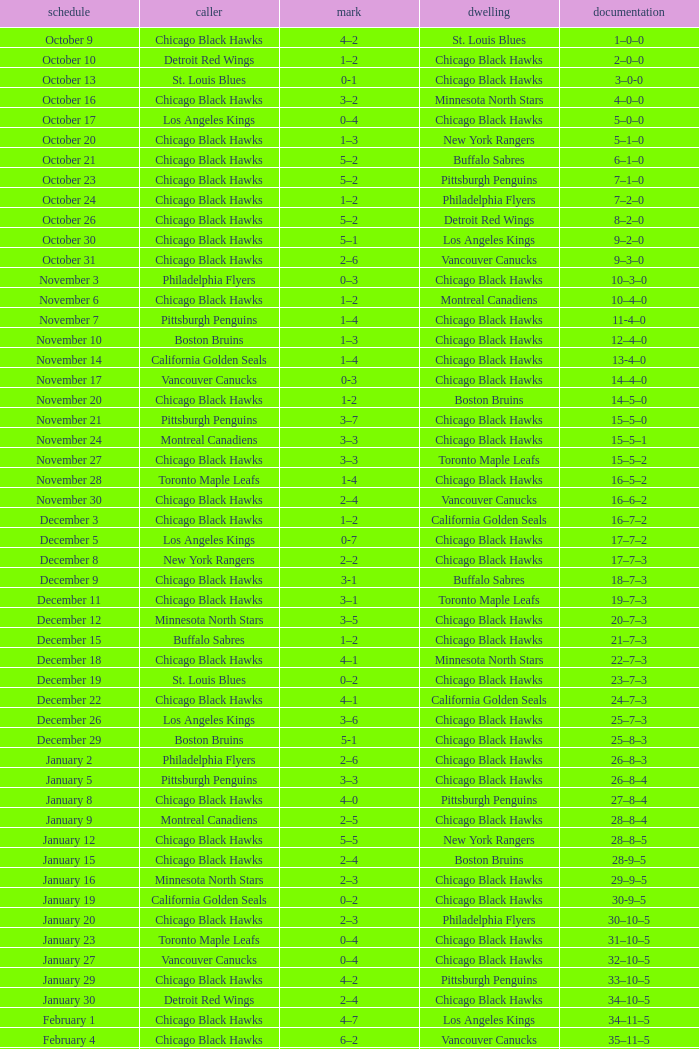Write the full table. {'header': ['schedule', 'caller', 'mark', 'dwelling', 'documentation'], 'rows': [['October 9', 'Chicago Black Hawks', '4–2', 'St. Louis Blues', '1–0–0'], ['October 10', 'Detroit Red Wings', '1–2', 'Chicago Black Hawks', '2–0–0'], ['October 13', 'St. Louis Blues', '0-1', 'Chicago Black Hawks', '3–0-0'], ['October 16', 'Chicago Black Hawks', '3–2', 'Minnesota North Stars', '4–0–0'], ['October 17', 'Los Angeles Kings', '0–4', 'Chicago Black Hawks', '5–0–0'], ['October 20', 'Chicago Black Hawks', '1–3', 'New York Rangers', '5–1–0'], ['October 21', 'Chicago Black Hawks', '5–2', 'Buffalo Sabres', '6–1–0'], ['October 23', 'Chicago Black Hawks', '5–2', 'Pittsburgh Penguins', '7–1–0'], ['October 24', 'Chicago Black Hawks', '1–2', 'Philadelphia Flyers', '7–2–0'], ['October 26', 'Chicago Black Hawks', '5–2', 'Detroit Red Wings', '8–2–0'], ['October 30', 'Chicago Black Hawks', '5–1', 'Los Angeles Kings', '9–2–0'], ['October 31', 'Chicago Black Hawks', '2–6', 'Vancouver Canucks', '9–3–0'], ['November 3', 'Philadelphia Flyers', '0–3', 'Chicago Black Hawks', '10–3–0'], ['November 6', 'Chicago Black Hawks', '1–2', 'Montreal Canadiens', '10–4–0'], ['November 7', 'Pittsburgh Penguins', '1–4', 'Chicago Black Hawks', '11-4–0'], ['November 10', 'Boston Bruins', '1–3', 'Chicago Black Hawks', '12–4–0'], ['November 14', 'California Golden Seals', '1–4', 'Chicago Black Hawks', '13-4–0'], ['November 17', 'Vancouver Canucks', '0-3', 'Chicago Black Hawks', '14–4–0'], ['November 20', 'Chicago Black Hawks', '1-2', 'Boston Bruins', '14–5–0'], ['November 21', 'Pittsburgh Penguins', '3–7', 'Chicago Black Hawks', '15–5–0'], ['November 24', 'Montreal Canadiens', '3–3', 'Chicago Black Hawks', '15–5–1'], ['November 27', 'Chicago Black Hawks', '3–3', 'Toronto Maple Leafs', '15–5–2'], ['November 28', 'Toronto Maple Leafs', '1-4', 'Chicago Black Hawks', '16–5–2'], ['November 30', 'Chicago Black Hawks', '2–4', 'Vancouver Canucks', '16–6–2'], ['December 3', 'Chicago Black Hawks', '1–2', 'California Golden Seals', '16–7–2'], ['December 5', 'Los Angeles Kings', '0-7', 'Chicago Black Hawks', '17–7–2'], ['December 8', 'New York Rangers', '2–2', 'Chicago Black Hawks', '17–7–3'], ['December 9', 'Chicago Black Hawks', '3-1', 'Buffalo Sabres', '18–7–3'], ['December 11', 'Chicago Black Hawks', '3–1', 'Toronto Maple Leafs', '19–7–3'], ['December 12', 'Minnesota North Stars', '3–5', 'Chicago Black Hawks', '20–7–3'], ['December 15', 'Buffalo Sabres', '1–2', 'Chicago Black Hawks', '21–7–3'], ['December 18', 'Chicago Black Hawks', '4–1', 'Minnesota North Stars', '22–7–3'], ['December 19', 'St. Louis Blues', '0–2', 'Chicago Black Hawks', '23–7–3'], ['December 22', 'Chicago Black Hawks', '4–1', 'California Golden Seals', '24–7–3'], ['December 26', 'Los Angeles Kings', '3–6', 'Chicago Black Hawks', '25–7–3'], ['December 29', 'Boston Bruins', '5-1', 'Chicago Black Hawks', '25–8–3'], ['January 2', 'Philadelphia Flyers', '2–6', 'Chicago Black Hawks', '26–8–3'], ['January 5', 'Pittsburgh Penguins', '3–3', 'Chicago Black Hawks', '26–8–4'], ['January 8', 'Chicago Black Hawks', '4–0', 'Pittsburgh Penguins', '27–8–4'], ['January 9', 'Montreal Canadiens', '2–5', 'Chicago Black Hawks', '28–8–4'], ['January 12', 'Chicago Black Hawks', '5–5', 'New York Rangers', '28–8–5'], ['January 15', 'Chicago Black Hawks', '2–4', 'Boston Bruins', '28-9–5'], ['January 16', 'Minnesota North Stars', '2–3', 'Chicago Black Hawks', '29–9–5'], ['January 19', 'California Golden Seals', '0–2', 'Chicago Black Hawks', '30-9–5'], ['January 20', 'Chicago Black Hawks', '2–3', 'Philadelphia Flyers', '30–10–5'], ['January 23', 'Toronto Maple Leafs', '0–4', 'Chicago Black Hawks', '31–10–5'], ['January 27', 'Vancouver Canucks', '0–4', 'Chicago Black Hawks', '32–10–5'], ['January 29', 'Chicago Black Hawks', '4–2', 'Pittsburgh Penguins', '33–10–5'], ['January 30', 'Detroit Red Wings', '2–4', 'Chicago Black Hawks', '34–10–5'], ['February 1', 'Chicago Black Hawks', '4–7', 'Los Angeles Kings', '34–11–5'], ['February 4', 'Chicago Black Hawks', '6–2', 'Vancouver Canucks', '35–11–5'], ['February 6', 'Minnesota North Stars', '0–5', 'Chicago Black Hawks', '36–11–5'], ['February 9', 'Chicago Black Hawks', '1–4', 'New York Rangers', '36–12–5'], ['February 10', 'Chicago Black Hawks', '1–7', 'Montreal Canadiens', '36–13–5'], ['February 12', 'Chicago Black Hawks', '3-3', 'Detroit Red Wings', '36–13–6'], ['February 13', 'Toronto Maple Leafs', '1–3', 'Chicago Black Hawks', '37–13–6'], ['February 15', 'Chicago Black Hawks', '3–2', 'St. Louis Blues', '38–13–6'], ['February 16', 'Philadelphia Flyers', '3–3', 'Chicago Black Hawks', '38–13–7'], ['February 20', 'Boston Bruins', '3–1', 'Chicago Black Hawks', '38–14–7'], ['February 23', 'Buffalo Sabres', '2–1', 'Chicago Black Hawks', '38–15–7'], ['February 24', 'Chicago Black Hawks', '3–5', 'Buffalo Sabres', '38–16–7'], ['February 26', 'California Golden Seals', '0–3', 'Chicago Black Hawks', '39–16–7'], ['February 27', 'Vancouver Canucks', '3–3', 'Chicago Black Hawks', '39–16–8'], ['March 1', 'Chicago Black Hawks', '6–4', 'Los Angeles Kings', '40–16–8'], ['March 3', 'Chicago Black Hawks', '4-4', 'California Golden Seals', '40–16–9'], ['March 5', 'Chicago Black Hawks', '1–2', 'Minnesota North Stars', '40–17–9'], ['March 8', 'Chicago Black Hawks', '3–3', 'New York Rangers', '40–17–10'], ['March 11', 'Chicago Black Hawks', '1–1', 'Montreal Canadiens', '40–17–11'], ['March 12', 'Chicago Black Hawks', '3–2', 'Detroit Red Wings', '41–17–11'], ['March 15', 'New York Rangers', '1–3', 'Chicago Black Hawks', '42–17–11'], ['March 18', 'Chicago Black Hawks', '2–2', 'Toronto Maple Leafs', '42–17–12'], ['March 19', 'Buffalo Sabres', '3–3', 'Chicago Black Hawks', '42–17-13'], ['March 23', 'Chicago Black Hawks', '4–2', 'Philadelphia Flyers', '43–17–13'], ['March 25', 'Chicago Black Hawks', '5–5', 'Boston Bruins', '43–17–14'], ['March 26', 'St. Louis Blues', '0–4', 'Chicago Black Hawks', '44–17–14'], ['March 29', 'Montreal Canadiens', '5–5', 'Chicago Black Hawks', '44–17–15'], ['April 1', 'Chicago Black Hawks', '2–0', 'St. Louis Blues', '45–17–15'], ['April 2', 'Detroit Red Wings', '1–6', 'Chicago Black Hawks', '46-17–15']]} What is the Record from February 10? 36–13–5. 